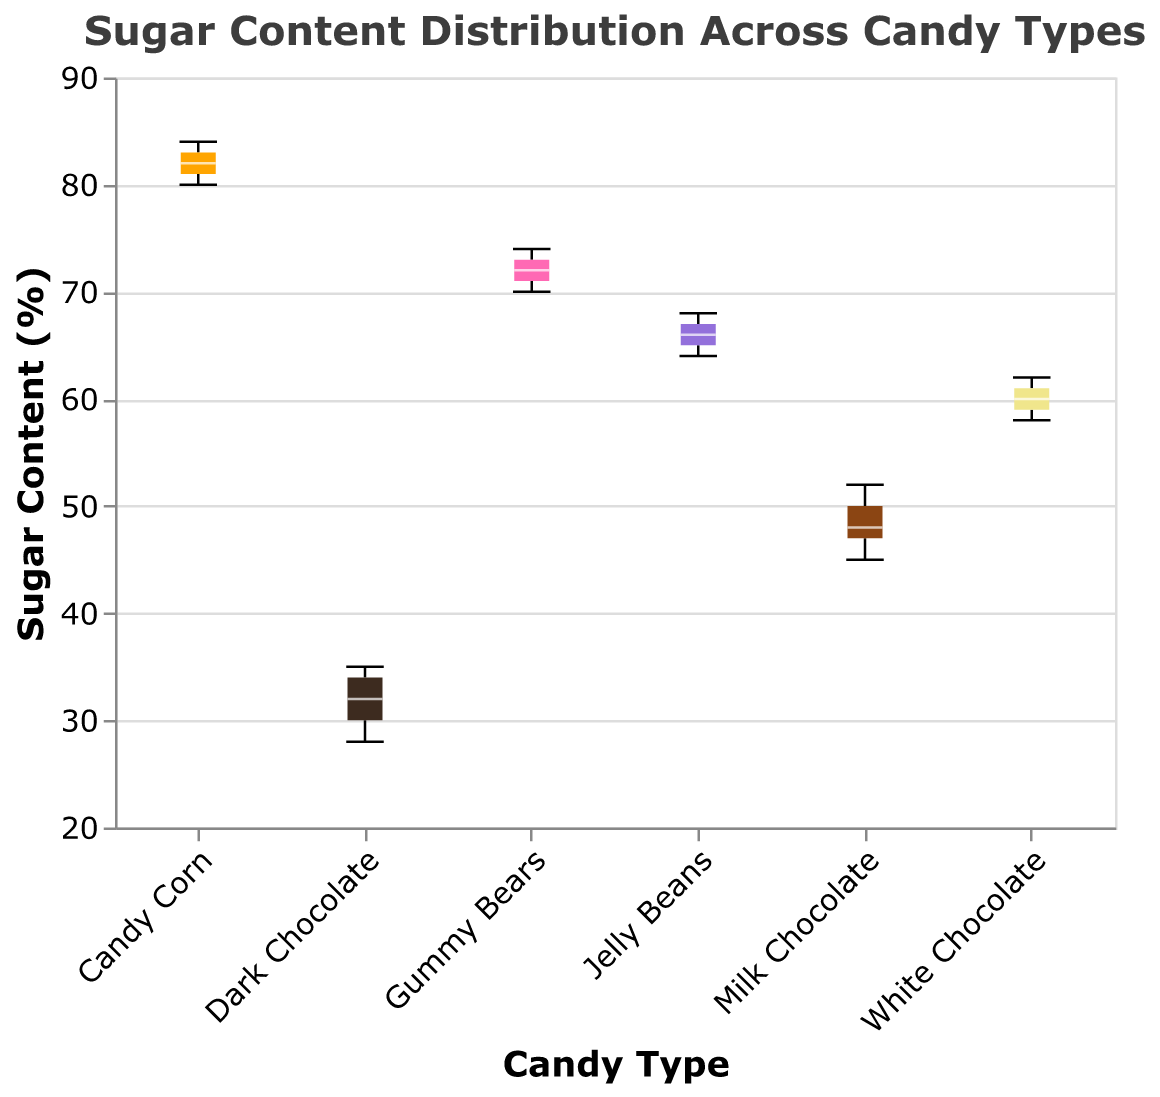What is the title of the figure? The title is located at the top of the figure and is typically larger in font size than other text elements. The title is clearly written above the boxplot.
Answer: Sugar Content Distribution Across Candy Types What is the range of sugar content for Dark Chocolate? The notched box plot visually shows the minimum and maximum points for each candy type. For Dark Chocolate, look at the whiskers' endpoints.
Answer: 28-35 Which candy type has the highest median sugar content? The median is the white line inside the box for each candy type. By comparing these lines, the candy type with the highest median will be identified.
Answer: Candy Corn What is the interquartile range (IQR) for Gummy Bears? The interquartile range (IQR) is the length of the box in the boxplot, which represents the middle 50% of the data. Look at the top and bottom of the box for Gummy Bears.
Answer: 70-73 Which candy type shows the most consistent sugar content, based on the boxplot? Consistency in this context is represented by the smallest interquartile range (IQR), or the shortest box. Compare the lengths of all the boxes.
Answer: Jelly Beans How does the median sugar content of White Chocolate compare to that of Milk Chocolate? Find the median lines for both White Chocolate and Milk Chocolate, then compare their positions on the y-axis.
Answer: White Chocolate has a higher median What does the size of the notch in each boxplot represent? In notched box plots, the notch represents the confidence interval around the median. The size of the notch indicates the approximate range where the true median lies.
Answer: Confidence interval around the median Between which two candy types is the difference in median sugar content the smallest? Compare the medians (white lines) of all candy types and find the pair with the closest values.
Answer: Jelly Beans and White Chocolate How many candy types have a median sugar content above 60%? Identify which candy types have their median lines above the 60% mark on the y-axis. Count the number of such candy types.
Answer: 3 Which candy type has the widest range of sugar content? The widest range is indicated by the length of the whiskers for each candy type. Find the candy type with the largest distance between its minimum and maximum whiskers.
Answer: Candy Corn 